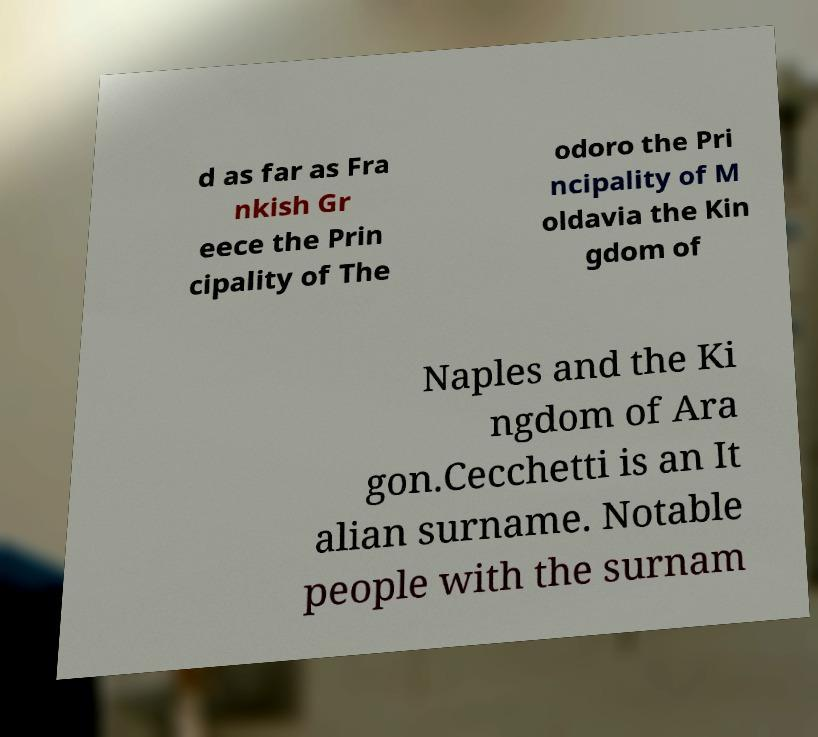I need the written content from this picture converted into text. Can you do that? d as far as Fra nkish Gr eece the Prin cipality of The odoro the Pri ncipality of M oldavia the Kin gdom of Naples and the Ki ngdom of Ara gon.Cecchetti is an It alian surname. Notable people with the surnam 